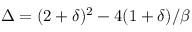Convert formula to latex. <formula><loc_0><loc_0><loc_500><loc_500>\Delta = ( 2 + \delta ) ^ { 2 } - 4 ( { 1 + \delta } ) / \beta</formula> 